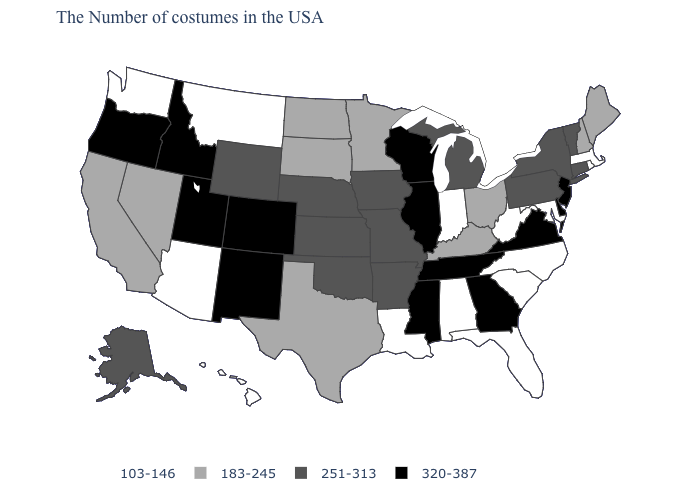Among the states that border Nevada , does Arizona have the lowest value?
Give a very brief answer. Yes. What is the highest value in the USA?
Answer briefly. 320-387. Which states have the lowest value in the USA?
Short answer required. Massachusetts, Rhode Island, Maryland, North Carolina, South Carolina, West Virginia, Florida, Indiana, Alabama, Louisiana, Montana, Arizona, Washington, Hawaii. Among the states that border South Carolina , does North Carolina have the lowest value?
Quick response, please. Yes. Is the legend a continuous bar?
Give a very brief answer. No. Which states hav the highest value in the Northeast?
Concise answer only. New Jersey. Which states have the lowest value in the South?
Short answer required. Maryland, North Carolina, South Carolina, West Virginia, Florida, Alabama, Louisiana. Name the states that have a value in the range 320-387?
Keep it brief. New Jersey, Delaware, Virginia, Georgia, Tennessee, Wisconsin, Illinois, Mississippi, Colorado, New Mexico, Utah, Idaho, Oregon. Name the states that have a value in the range 320-387?
Be succinct. New Jersey, Delaware, Virginia, Georgia, Tennessee, Wisconsin, Illinois, Mississippi, Colorado, New Mexico, Utah, Idaho, Oregon. What is the value of Rhode Island?
Short answer required. 103-146. Does Tennessee have the lowest value in the South?
Concise answer only. No. What is the lowest value in the South?
Short answer required. 103-146. Name the states that have a value in the range 251-313?
Write a very short answer. Vermont, Connecticut, New York, Pennsylvania, Michigan, Missouri, Arkansas, Iowa, Kansas, Nebraska, Oklahoma, Wyoming, Alaska. Is the legend a continuous bar?
Give a very brief answer. No. What is the lowest value in the USA?
Give a very brief answer. 103-146. 